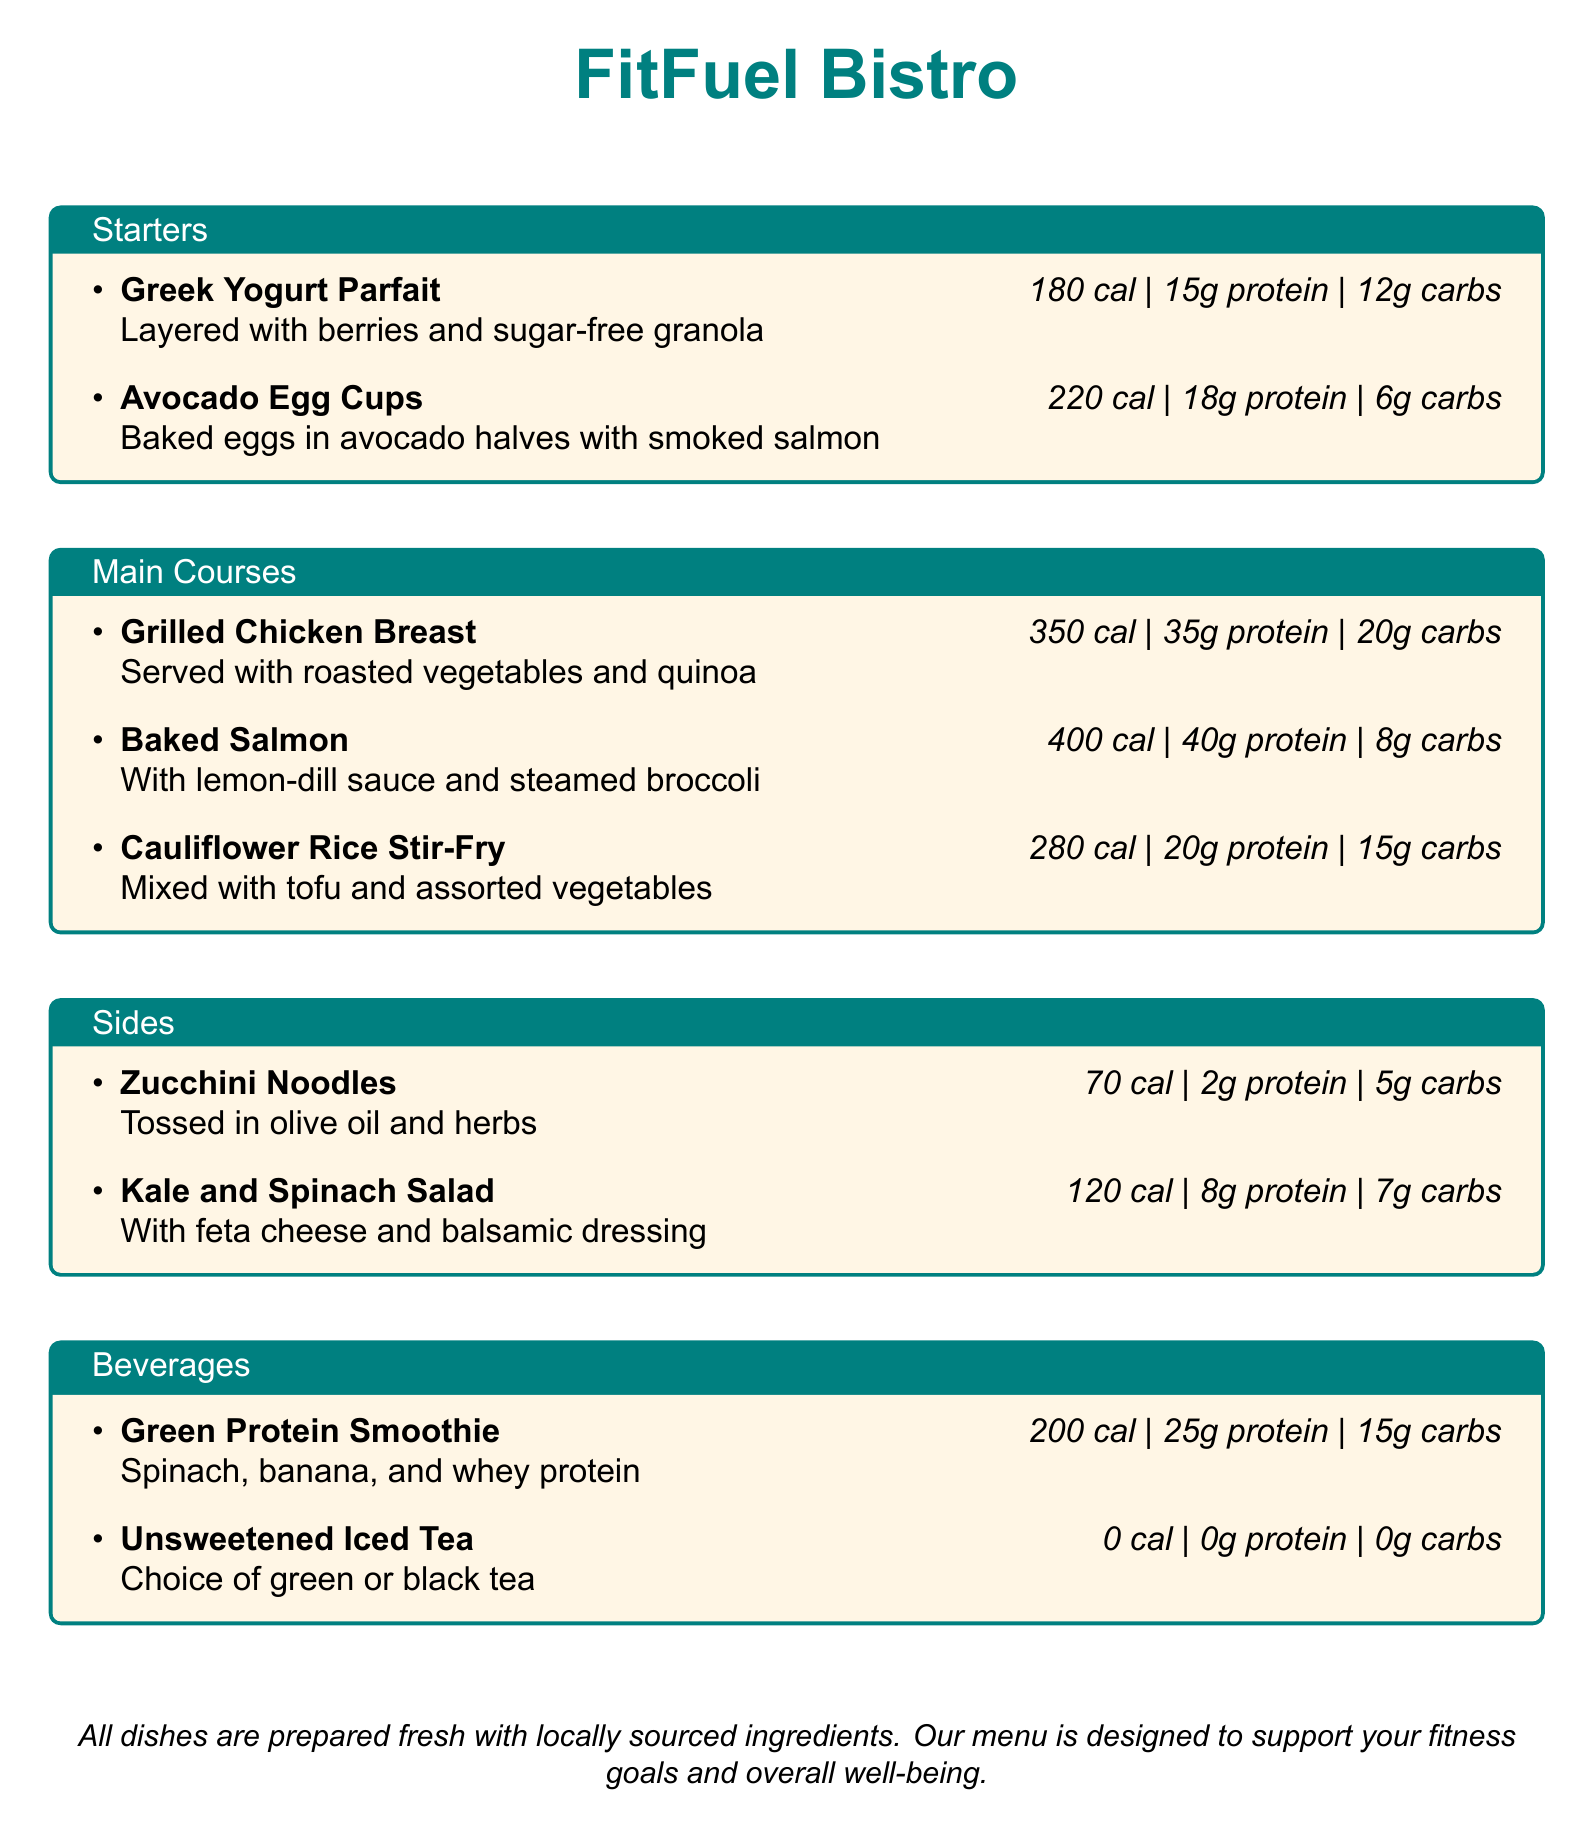What is the name of the restaurant? The name of the restaurant is found at the top of the document under the heading.
Answer: FitFuel Bistro What is the calorie count of the Grilled Chicken Breast? The calorie count is listed in the description of the dish within the "Main Courses" section.
Answer: 350 cal How much protein does the Avocado Egg Cups contain? The protein content is specified in the details of the dish in the "Starters" section.
Answer: 18g protein Which beverage has 0 calories? The document lists beverages with their calorie counts, and only one is at 0 calories.
Answer: Unsweetened Iced Tea What dish has the highest protein content? This requires comparing protein values across the courses in the menu to find the dish with the most.
Answer: Baked Salmon How many grams of carbs are in the Cauliflower Rice Stir-Fry? The carb content is indicated alongside the other nutritional information in the "Main Courses" section.
Answer: 15g carbs What is the primary ingredient in the Green Protein Smoothie? The main ingredients are mentioned in the description of the smoothie.
Answer: Spinach Which starter dish contains sugar-free granola? This information can be derived from the description provided in the "Starters" section.
Answer: Greek Yogurt Parfait What is the serving style of the Baked Salmon? The style is mentioned along with the dish in the "Main Courses" section.
Answer: With lemon-dill sauce and steamed broccoli 